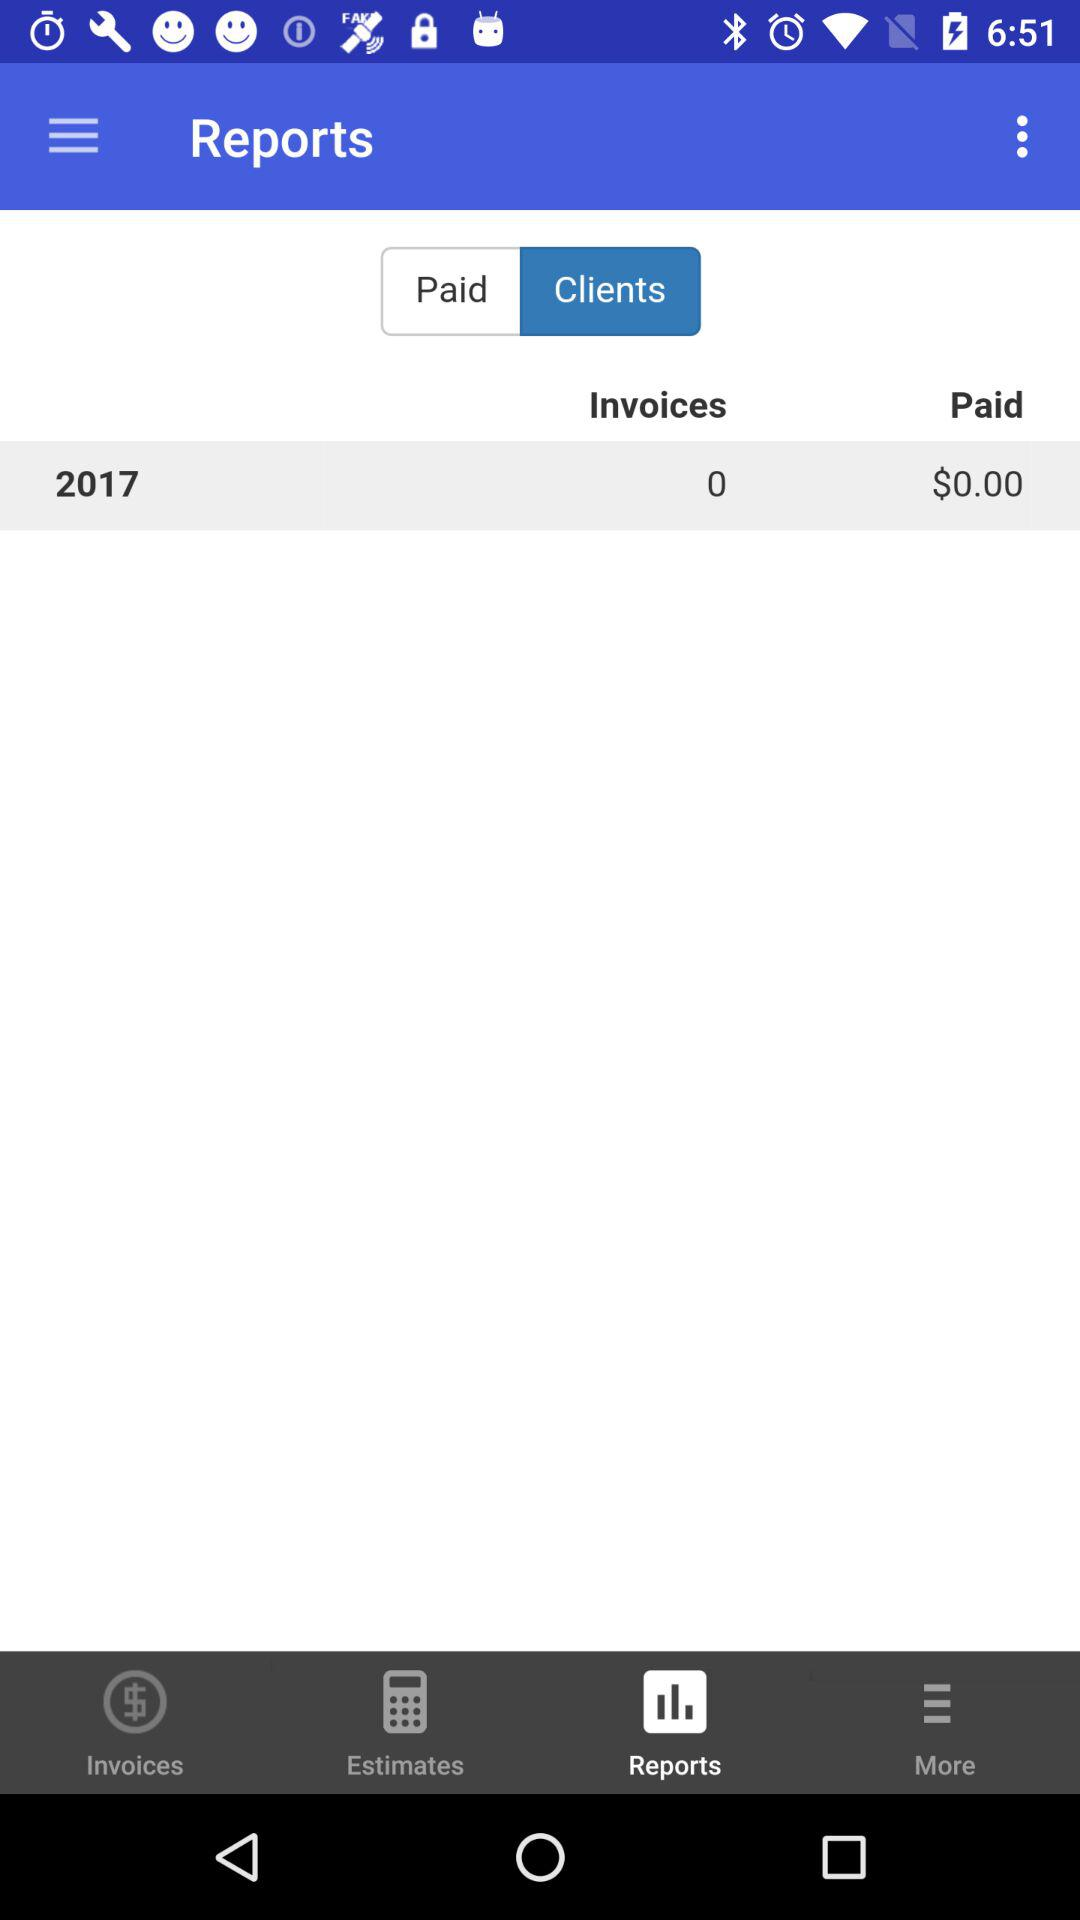How much money is owed in invoices?
Answer the question using a single word or phrase. $0.00 